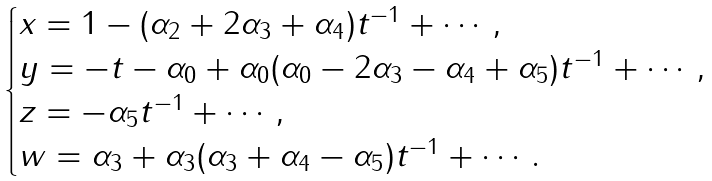Convert formula to latex. <formula><loc_0><loc_0><loc_500><loc_500>\begin{cases} x = 1 - ( \alpha _ { 2 } + 2 \alpha _ { 3 } + \alpha _ { 4 } ) t ^ { - 1 } + \cdots , \\ y = - t - \alpha _ { 0 } + \alpha _ { 0 } ( \alpha _ { 0 } - 2 \alpha _ { 3 } - \alpha _ { 4 } + \alpha _ { 5 } ) t ^ { - 1 } + \cdots , \\ z = - \alpha _ { 5 } t ^ { - 1 } + \cdots , \\ w = \alpha _ { 3 } + \alpha _ { 3 } ( \alpha _ { 3 } + \alpha _ { 4 } - \alpha _ { 5 } ) t ^ { - 1 } + \cdots . \end{cases}</formula> 